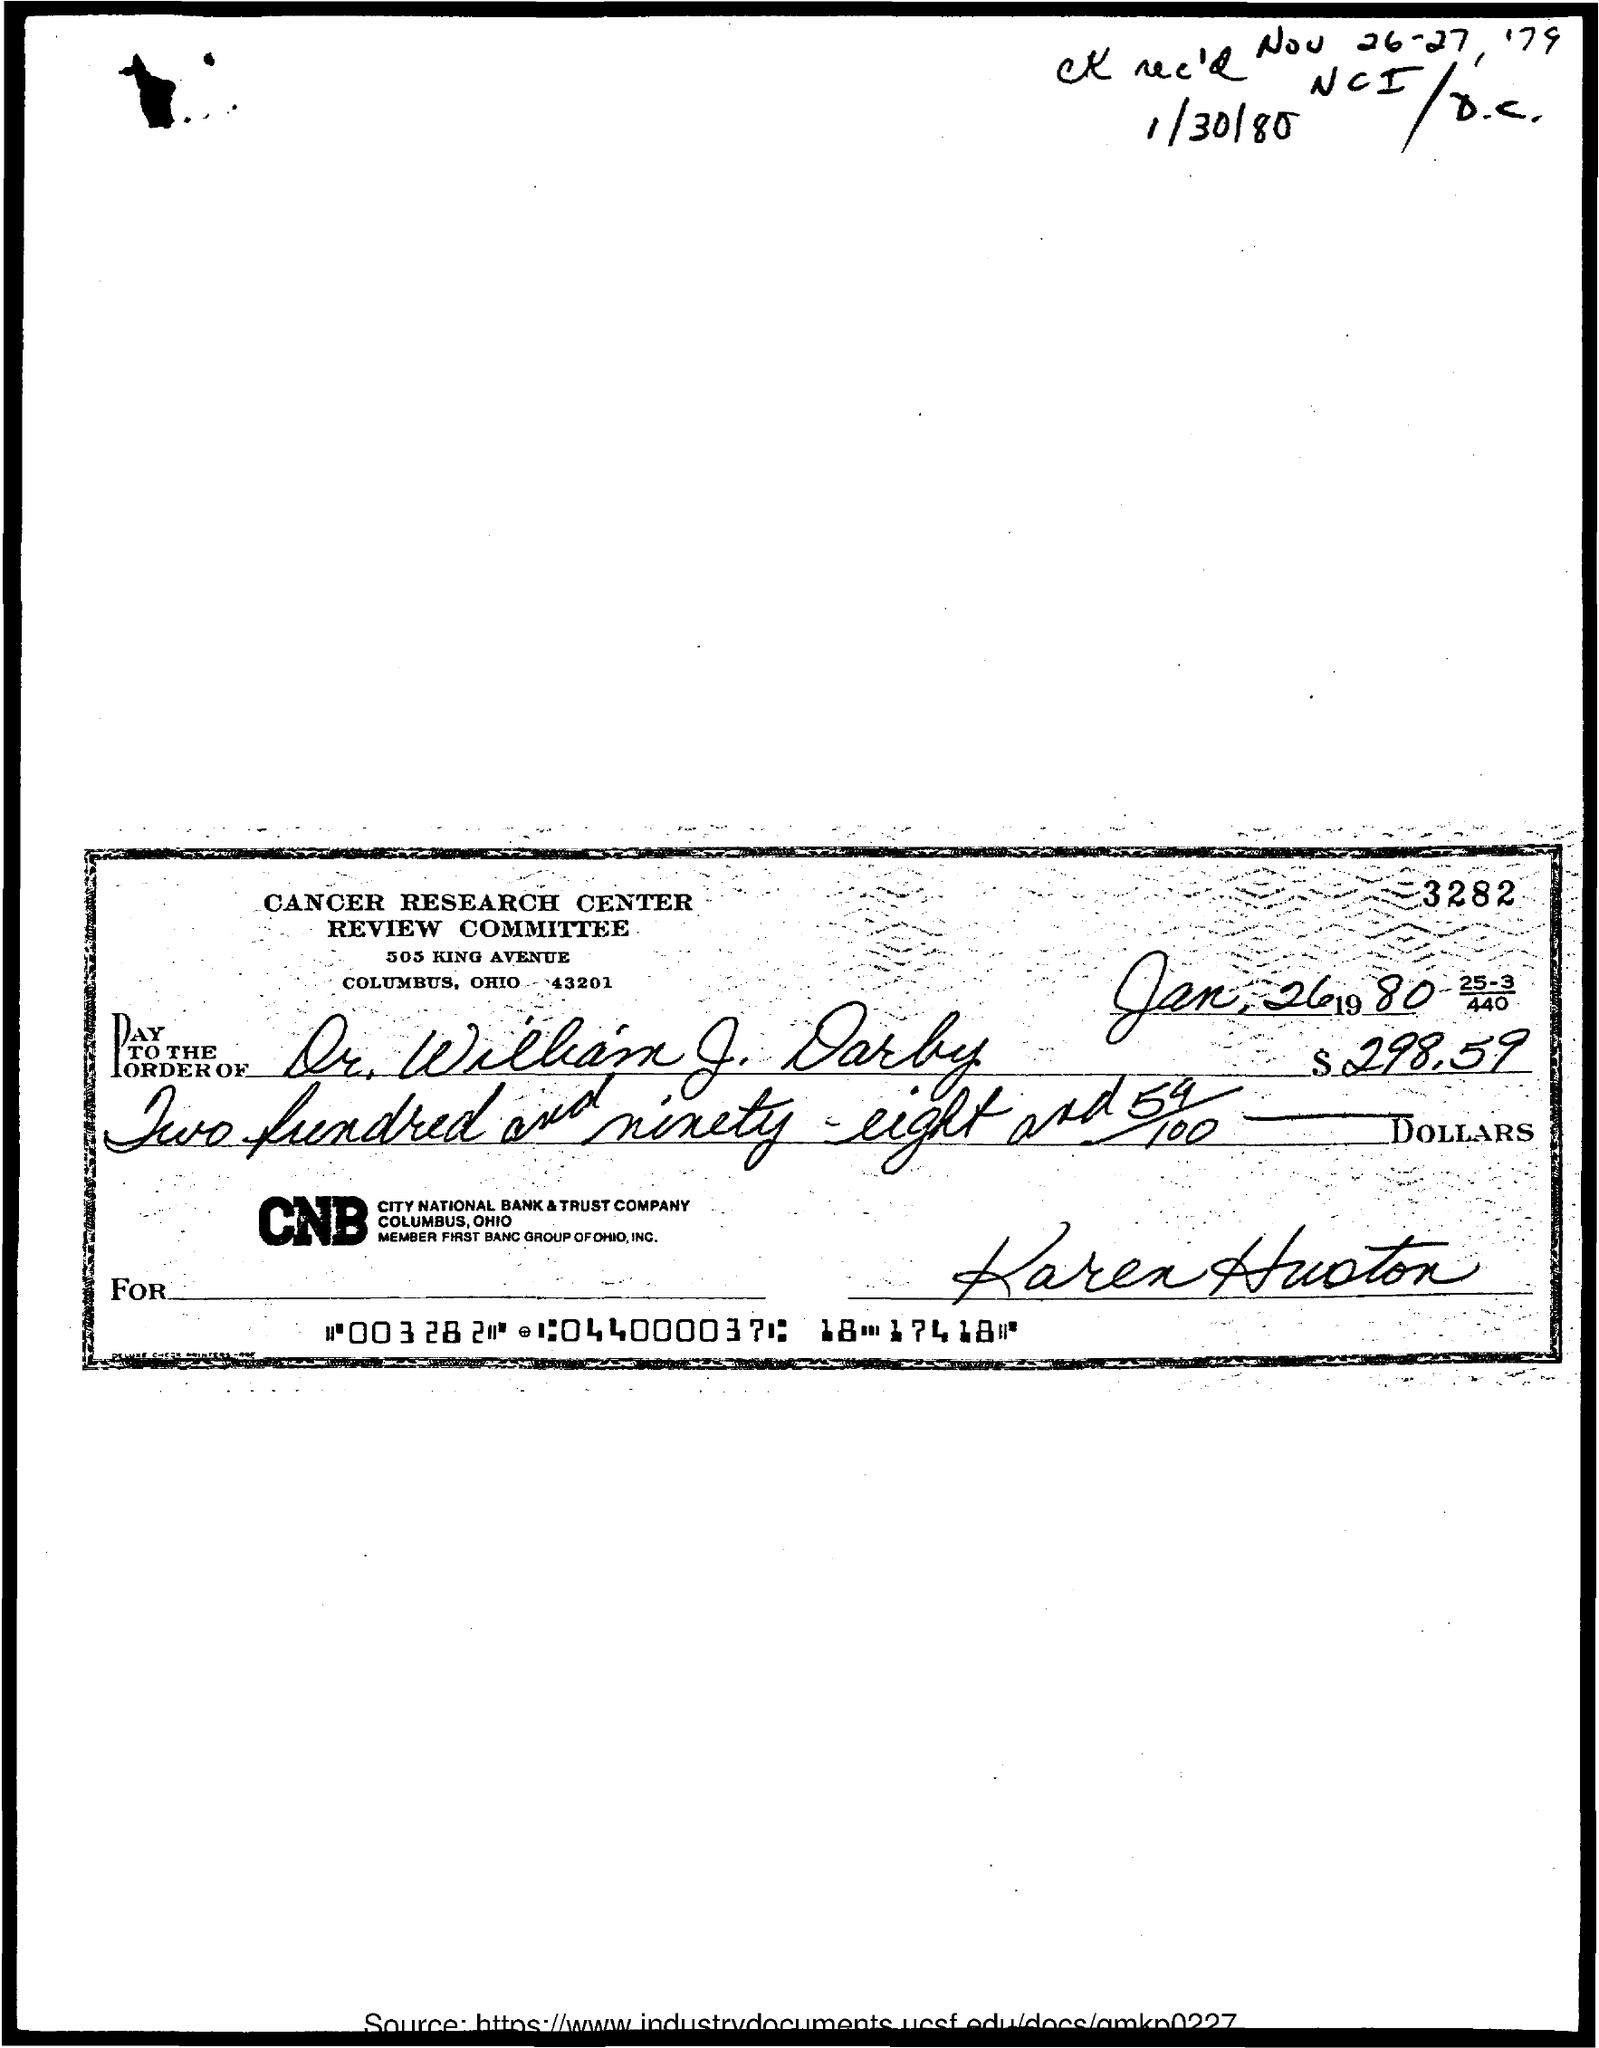Highlight a few significant elements in this photo. The amount mentioned in the check is $298.59. The issued date of this check is January 26, 1980, as indicated by the notation "Jan. 26 1980. The payee name on the check is "Dr. William J. Darby. 